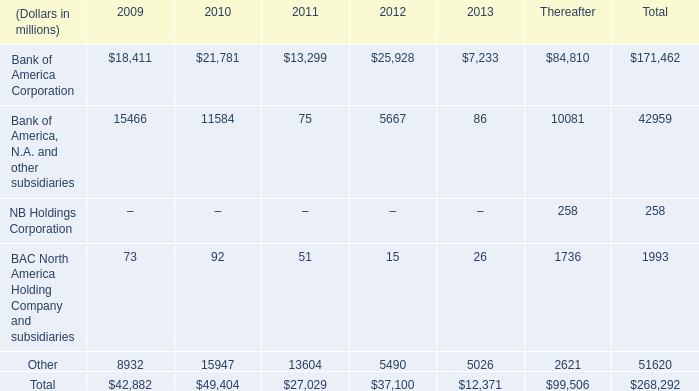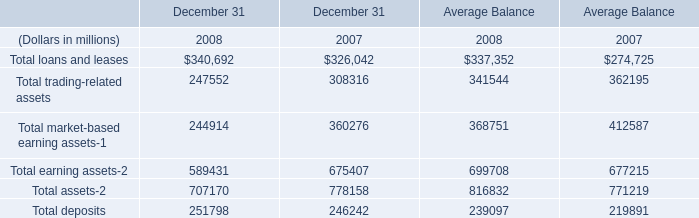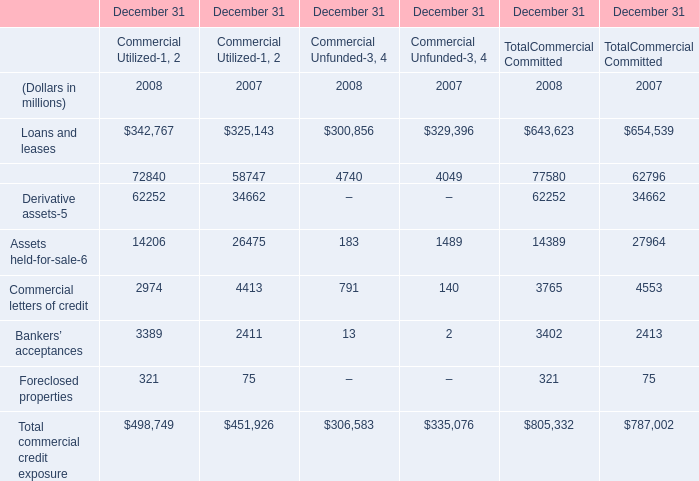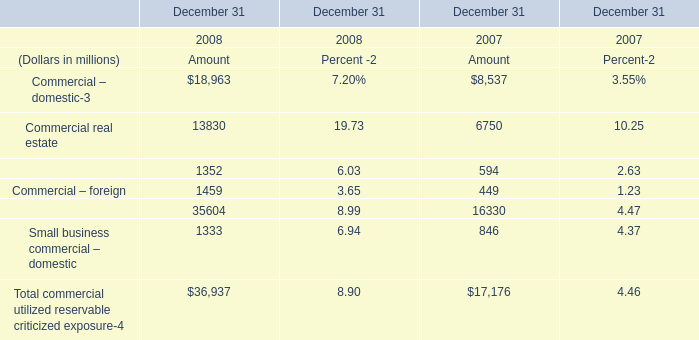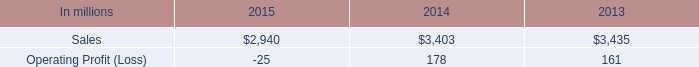What's the growth rate of small business commercial – domestic in 2008? 
Computations: ((1333 - 846) / 846)
Answer: 0.57565. 